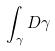<formula> <loc_0><loc_0><loc_500><loc_500>\int _ { \gamma } D \gamma</formula> 